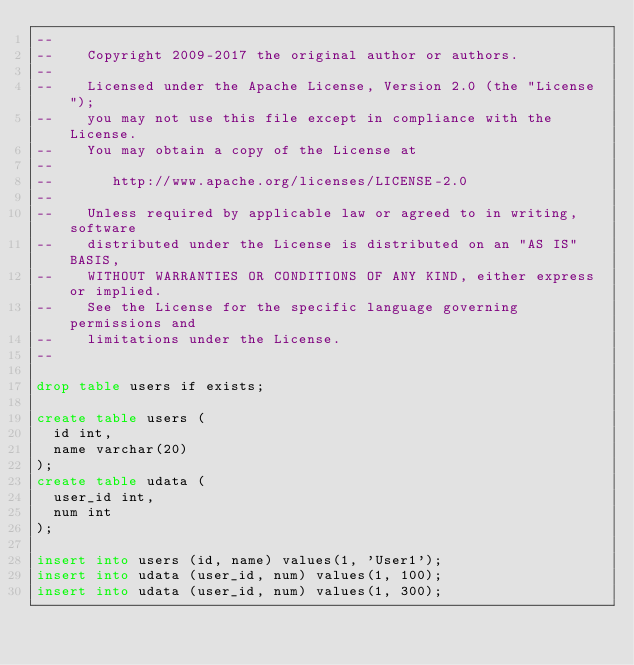Convert code to text. <code><loc_0><loc_0><loc_500><loc_500><_SQL_>--
--    Copyright 2009-2017 the original author or authors.
--
--    Licensed under the Apache License, Version 2.0 (the "License");
--    you may not use this file except in compliance with the License.
--    You may obtain a copy of the License at
--
--       http://www.apache.org/licenses/LICENSE-2.0
--
--    Unless required by applicable law or agreed to in writing, software
--    distributed under the License is distributed on an "AS IS" BASIS,
--    WITHOUT WARRANTIES OR CONDITIONS OF ANY KIND, either express or implied.
--    See the License for the specific language governing permissions and
--    limitations under the License.
--

drop table users if exists;

create table users (
  id int,
  name varchar(20)
);
create table udata (
  user_id int,
  num int
);

insert into users (id, name) values(1, 'User1');
insert into udata (user_id, num) values(1, 100);
insert into udata (user_id, num) values(1, 300);
</code> 